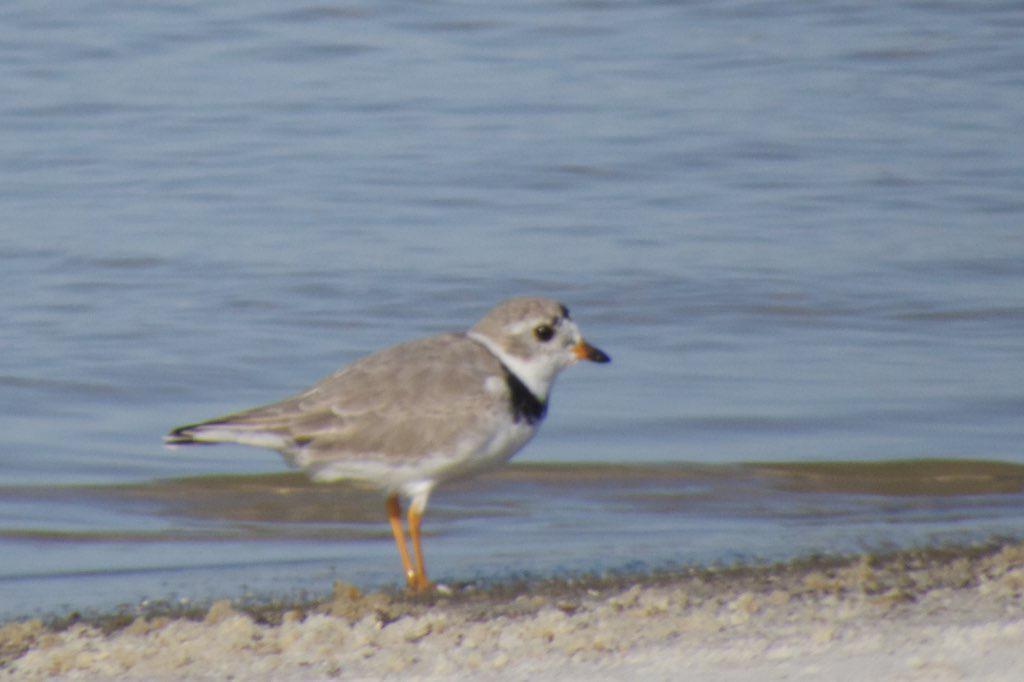Describe this image in one or two sentences. In this image, we can see a bird. At the bottom, there is a ground. Background we can see the water. 